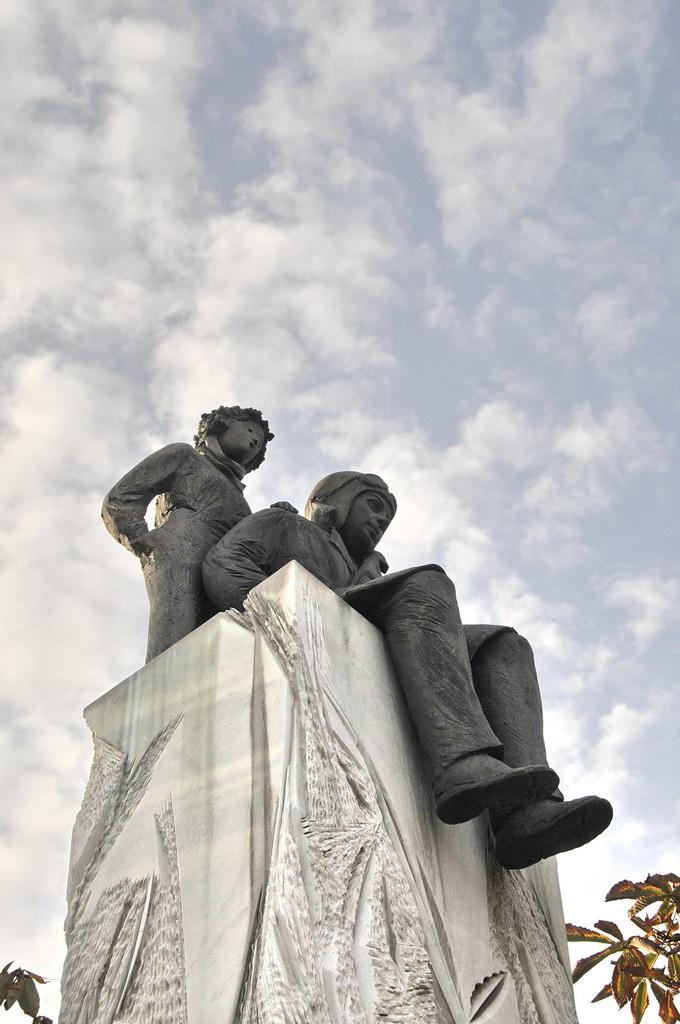In one or two sentences, can you explain what this image depicts? In this image I can see a white colour thing and on it I can see two sculptures. I can also see leaves, clouds and the sky. 